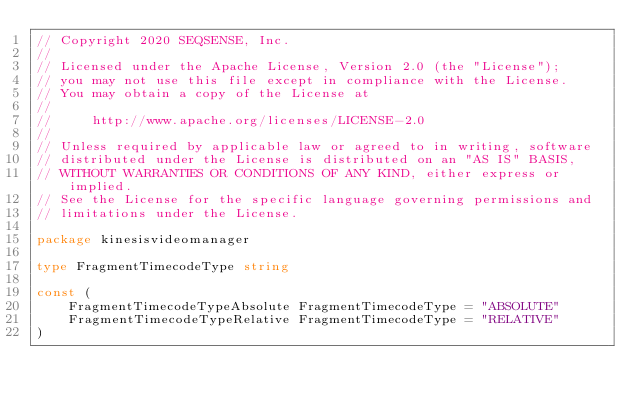Convert code to text. <code><loc_0><loc_0><loc_500><loc_500><_Go_>// Copyright 2020 SEQSENSE, Inc.
//
// Licensed under the Apache License, Version 2.0 (the "License");
// you may not use this file except in compliance with the License.
// You may obtain a copy of the License at
//
//     http://www.apache.org/licenses/LICENSE-2.0
//
// Unless required by applicable law or agreed to in writing, software
// distributed under the License is distributed on an "AS IS" BASIS,
// WITHOUT WARRANTIES OR CONDITIONS OF ANY KIND, either express or implied.
// See the License for the specific language governing permissions and
// limitations under the License.

package kinesisvideomanager

type FragmentTimecodeType string

const (
	FragmentTimecodeTypeAbsolute FragmentTimecodeType = "ABSOLUTE"
	FragmentTimecodeTypeRelative FragmentTimecodeType = "RELATIVE"
)
</code> 